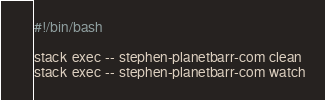Convert code to text. <code><loc_0><loc_0><loc_500><loc_500><_Bash_>#!/bin/bash

stack exec -- stephen-planetbarr-com clean
stack exec -- stephen-planetbarr-com watch

</code> 